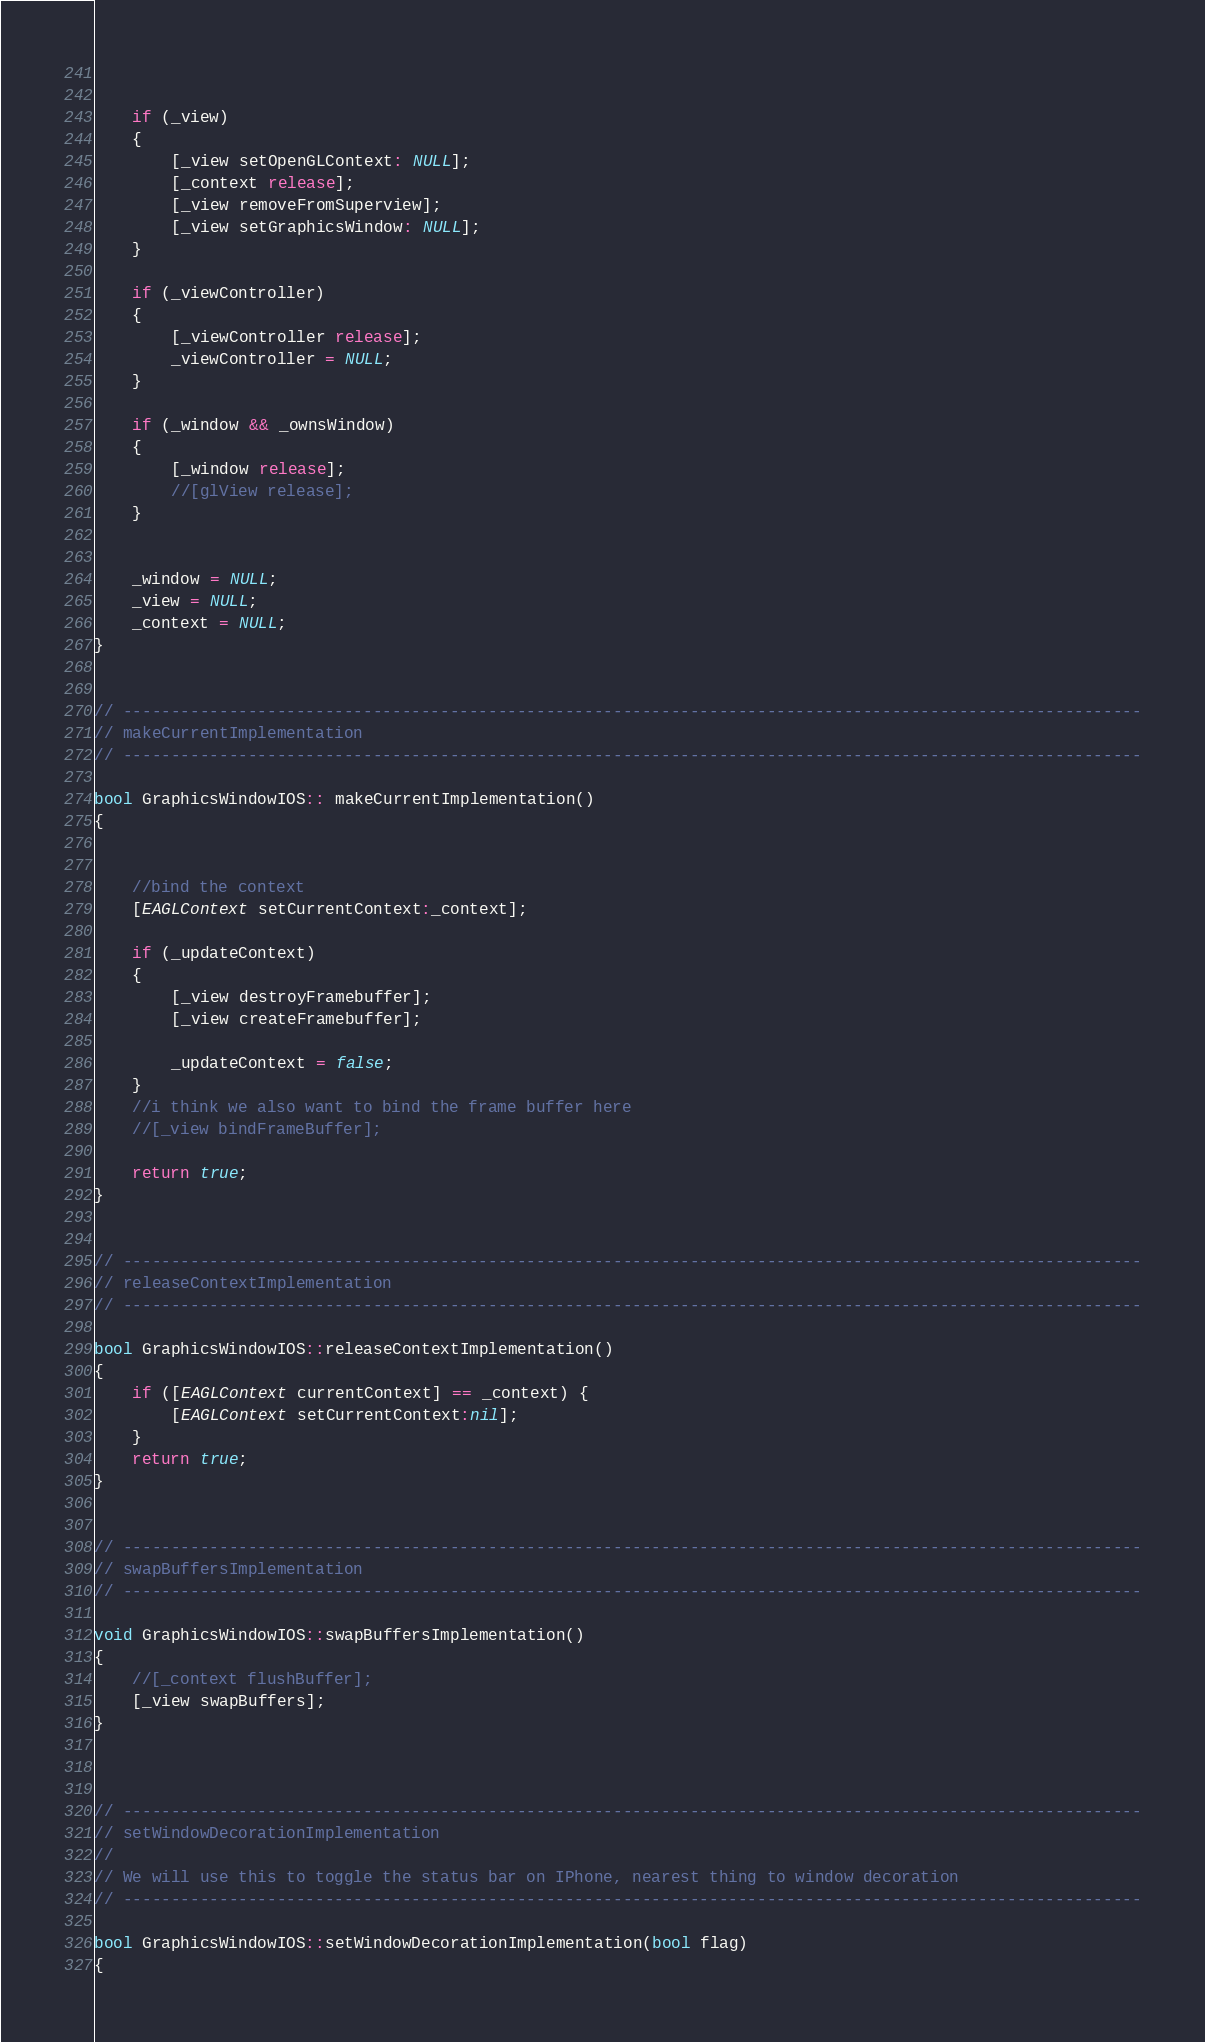<code> <loc_0><loc_0><loc_500><loc_500><_ObjectiveC_>   
    
    if (_view) 
    {
        [_view setOpenGLContext: NULL];
        [_context release];
        [_view removeFromSuperview];
        [_view setGraphicsWindow: NULL];
    }
    
    if (_viewController) 
    {
        [_viewController release];
        _viewController = NULL;
    }
        
    if (_window && _ownsWindow) 
    {  
        [_window release];
        //[glView release];
    }

    
    _window = NULL;
    _view = NULL;  
    _context = NULL;  
}


// ----------------------------------------------------------------------------------------------------------
// makeCurrentImplementation
// ----------------------------------------------------------------------------------------------------------

bool GraphicsWindowIOS:: makeCurrentImplementation()
{
    
    
    //bind the context
    [EAGLContext setCurrentContext:_context];
    
    if (_updateContext)
    {
        [_view destroyFramebuffer];
        [_view createFramebuffer];

        _updateContext = false; 
    }
    //i think we also want to bind the frame buffer here
    //[_view bindFrameBuffer];

    return true;
}


// ----------------------------------------------------------------------------------------------------------
// releaseContextImplementation
// ----------------------------------------------------------------------------------------------------------

bool GraphicsWindowIOS::releaseContextImplementation()
{
    if ([EAGLContext currentContext] == _context) {
        [EAGLContext setCurrentContext:nil];
    }
    return true;
}


// ----------------------------------------------------------------------------------------------------------
// swapBuffersImplementation
// ----------------------------------------------------------------------------------------------------------

void GraphicsWindowIOS::swapBuffersImplementation()
{
    //[_context flushBuffer];
    [_view swapBuffers];
}



// ----------------------------------------------------------------------------------------------------------
// setWindowDecorationImplementation
//
// We will use this to toggle the status bar on IPhone, nearest thing to window decoration
// ----------------------------------------------------------------------------------------------------------

bool GraphicsWindowIOS::setWindowDecorationImplementation(bool flag)
{</code> 